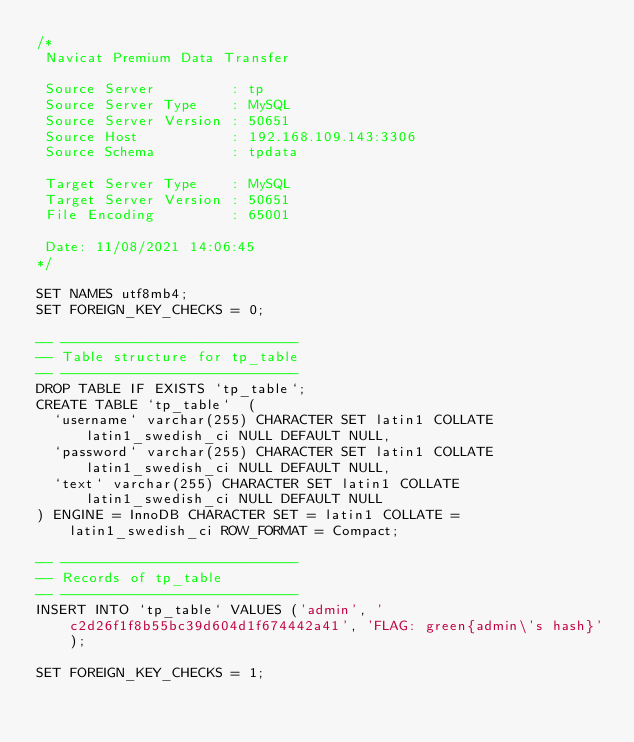<code> <loc_0><loc_0><loc_500><loc_500><_SQL_>/*
 Navicat Premium Data Transfer

 Source Server         : tp
 Source Server Type    : MySQL
 Source Server Version : 50651
 Source Host           : 192.168.109.143:3306
 Source Schema         : tpdata

 Target Server Type    : MySQL
 Target Server Version : 50651
 File Encoding         : 65001

 Date: 11/08/2021 14:06:45
*/

SET NAMES utf8mb4;
SET FOREIGN_KEY_CHECKS = 0;

-- ----------------------------
-- Table structure for tp_table
-- ----------------------------
DROP TABLE IF EXISTS `tp_table`;
CREATE TABLE `tp_table`  (
  `username` varchar(255) CHARACTER SET latin1 COLLATE latin1_swedish_ci NULL DEFAULT NULL,
  `password` varchar(255) CHARACTER SET latin1 COLLATE latin1_swedish_ci NULL DEFAULT NULL,
  `text` varchar(255) CHARACTER SET latin1 COLLATE latin1_swedish_ci NULL DEFAULT NULL
) ENGINE = InnoDB CHARACTER SET = latin1 COLLATE = latin1_swedish_ci ROW_FORMAT = Compact;

-- ----------------------------
-- Records of tp_table
-- ----------------------------
INSERT INTO `tp_table` VALUES ('admin', 'c2d26f1f8b55bc39d604d1f674442a41', 'FLAG: green{admin\'s hash}');

SET FOREIGN_KEY_CHECKS = 1;
</code> 